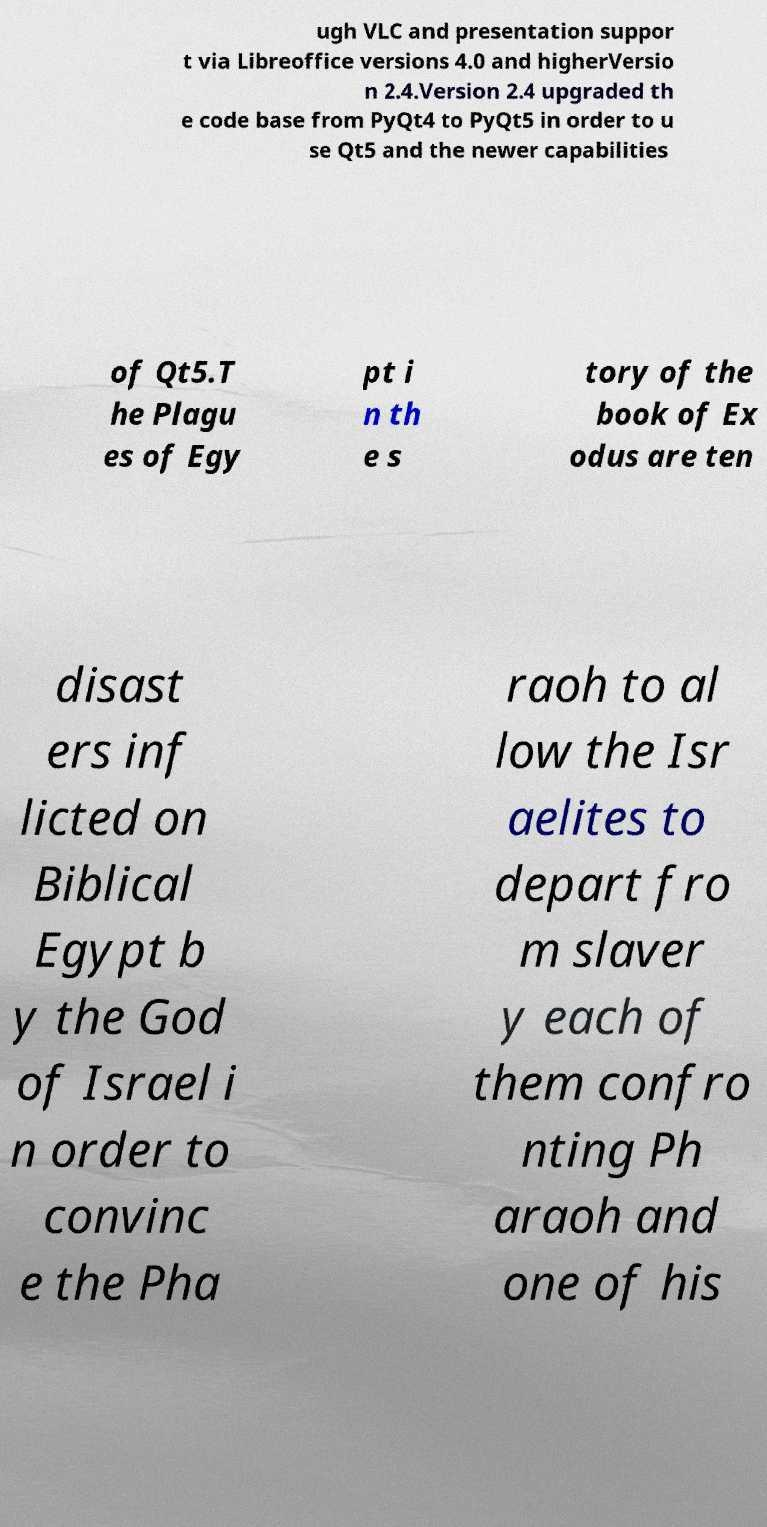What messages or text are displayed in this image? I need them in a readable, typed format. ugh VLC and presentation suppor t via Libreoffice versions 4.0 and higherVersio n 2.4.Version 2.4 upgraded th e code base from PyQt4 to PyQt5 in order to u se Qt5 and the newer capabilities of Qt5.T he Plagu es of Egy pt i n th e s tory of the book of Ex odus are ten disast ers inf licted on Biblical Egypt b y the God of Israel i n order to convinc e the Pha raoh to al low the Isr aelites to depart fro m slaver y each of them confro nting Ph araoh and one of his 